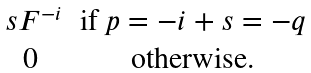<formula> <loc_0><loc_0><loc_500><loc_500>\begin{matrix} \ s F ^ { - i } & \text {if $p=-i+s=-q$} \\ 0 & \text {otherwise.} \\ \end{matrix}</formula> 